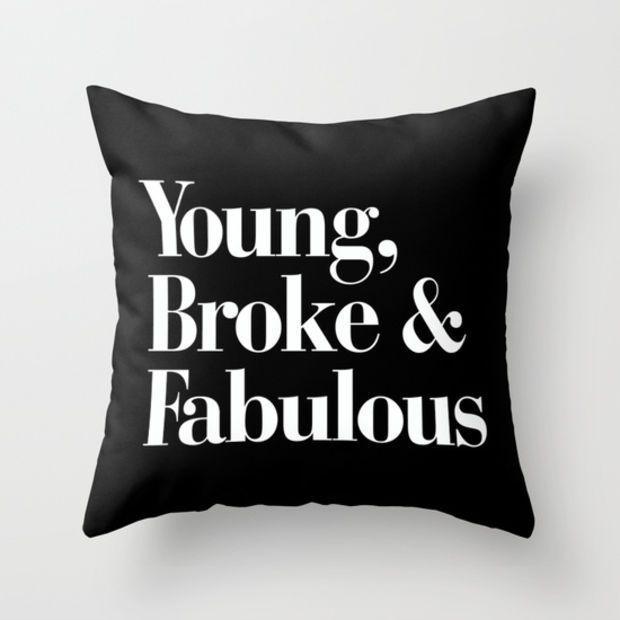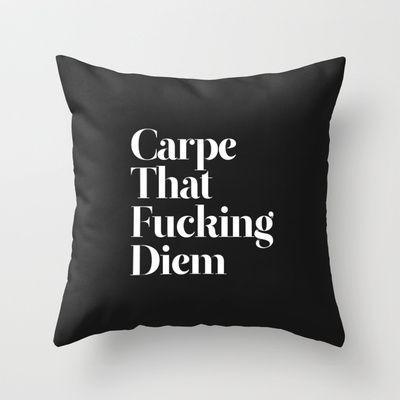The first image is the image on the left, the second image is the image on the right. Evaluate the accuracy of this statement regarding the images: "IN at least one image there is a light gray pillow with at least five lines of white writing.". Is it true? Answer yes or no. No. The first image is the image on the left, the second image is the image on the right. Examine the images to the left and right. Is the description "All pillows feature text as their primary decoration, and at least one pillow is dark black with bold white lettering." accurate? Answer yes or no. Yes. 